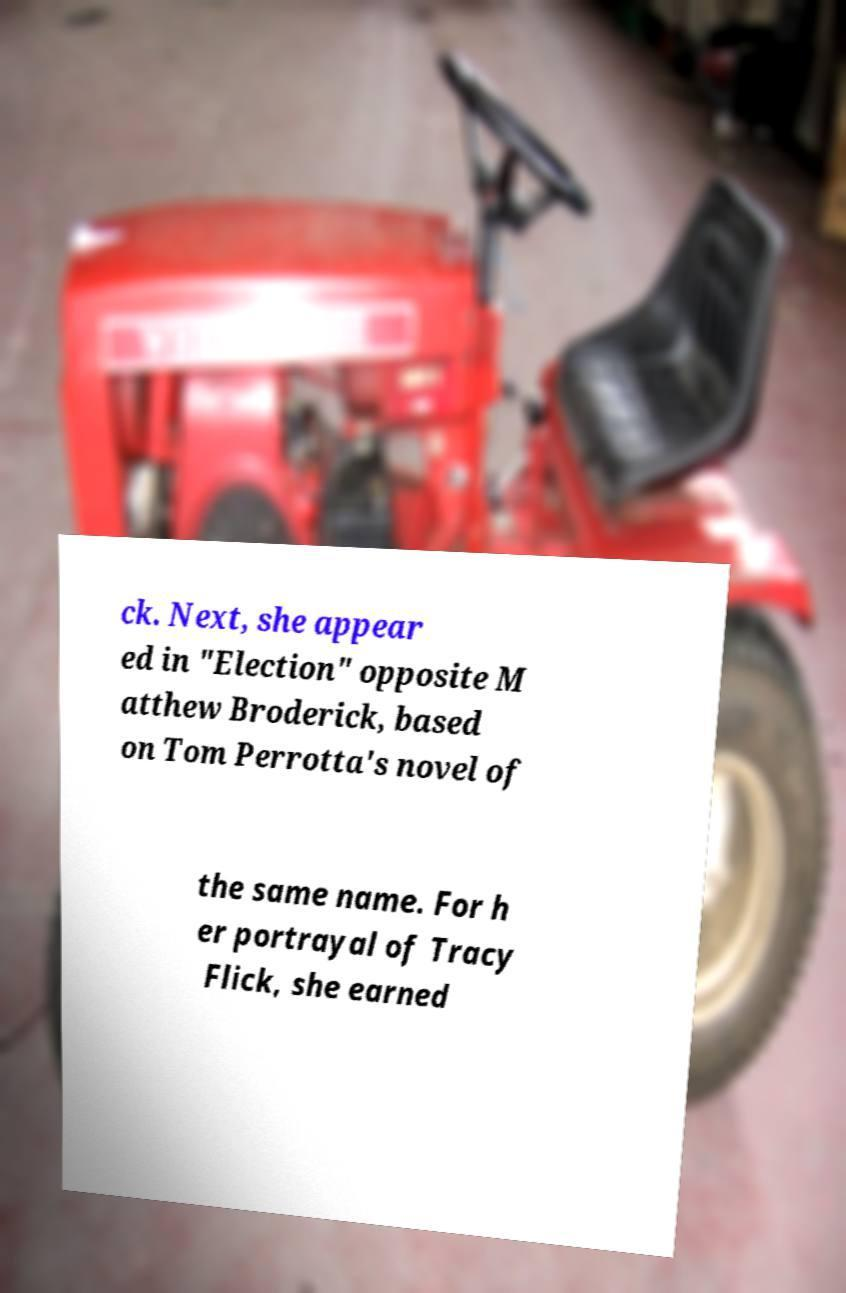For documentation purposes, I need the text within this image transcribed. Could you provide that? ck. Next, she appear ed in "Election" opposite M atthew Broderick, based on Tom Perrotta's novel of the same name. For h er portrayal of Tracy Flick, she earned 